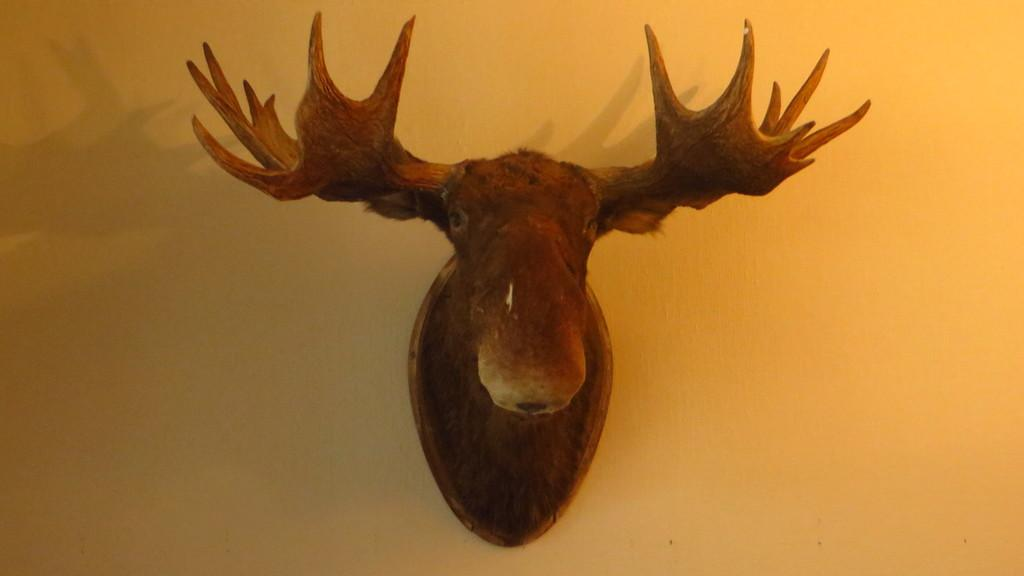What can be seen on the wall in the image? There is a decor placed on the wall in the image. How many tents are visible in the image? There are no tents present in the image; it only features a decor placed on the wall. What type of cent can be seen interacting with the decor in the image? There is no cent or any other creature present in the image; only the decor is visible on the wall. 